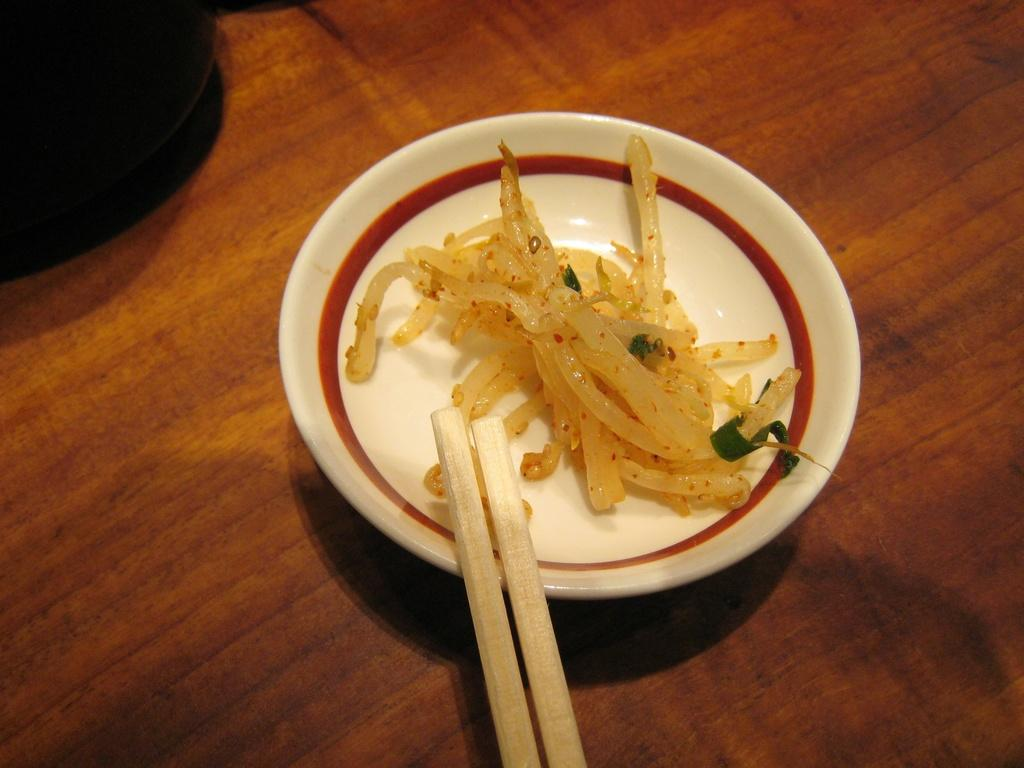What type of food can be seen in the image? There is food in the image, but the specific type is not mentioned. What else is present in the image besides the food? There are sticks in the image. How are the food and sticks arranged in the image? The food and sticks are in a plate. What color is the underwear of the person who prepared the food in the image? There is no person or underwear mentioned in the image, so we cannot determine the color of any underwear. 